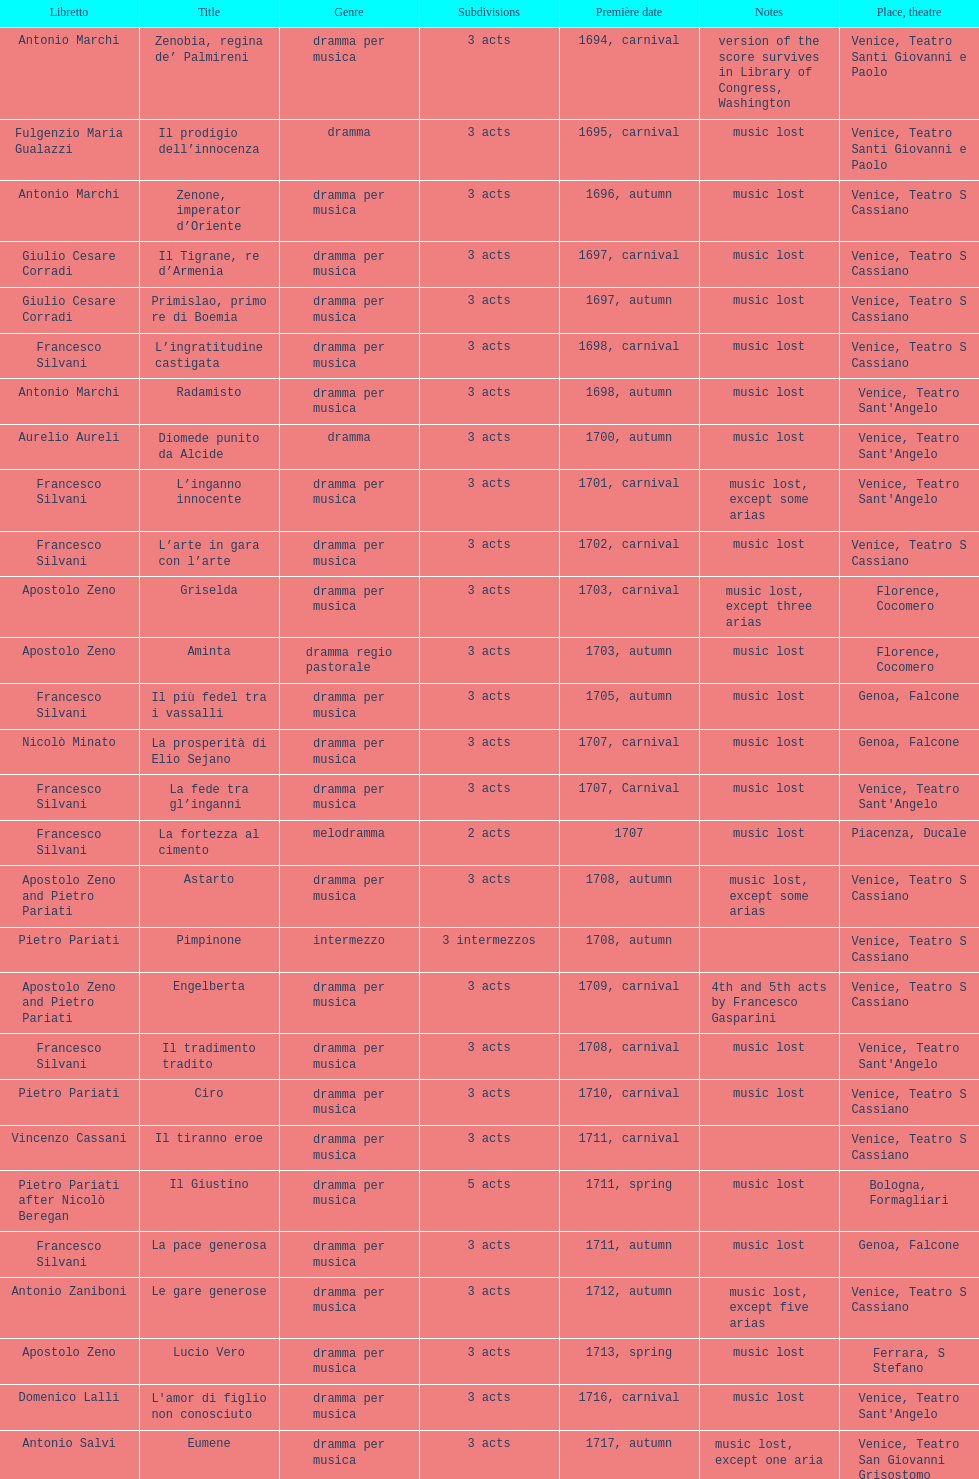What number of acts does il giustino have? 5. 